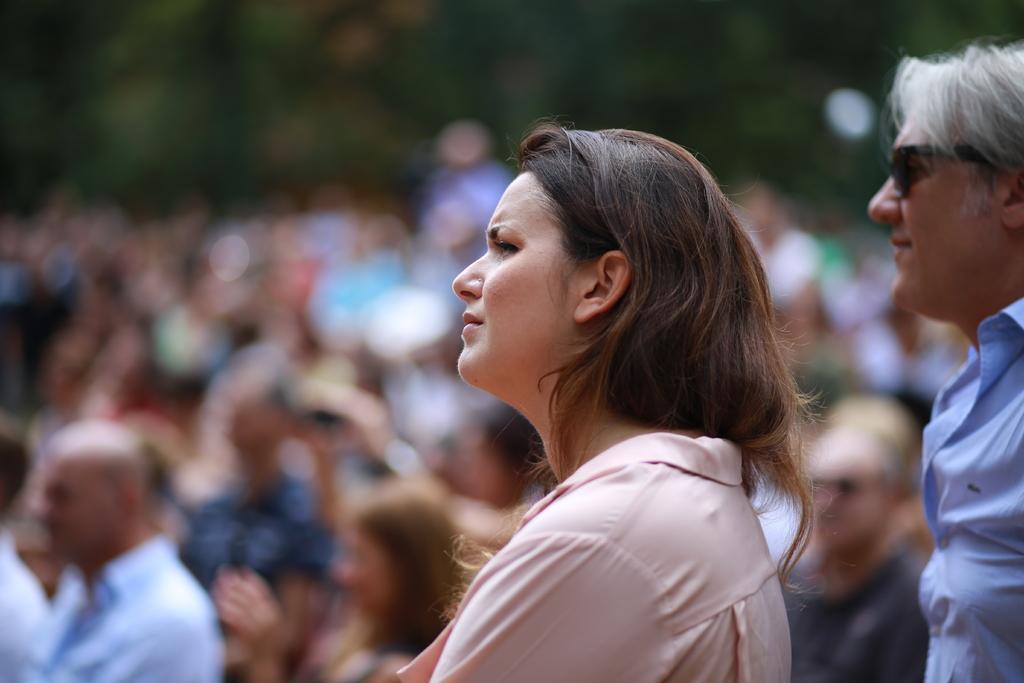How would you summarize this image in a sentence or two? In this image we can see one man and woman is present. Man is wearing blue color shirt and the woman is wearing pink color shirt. Behind people are present. 